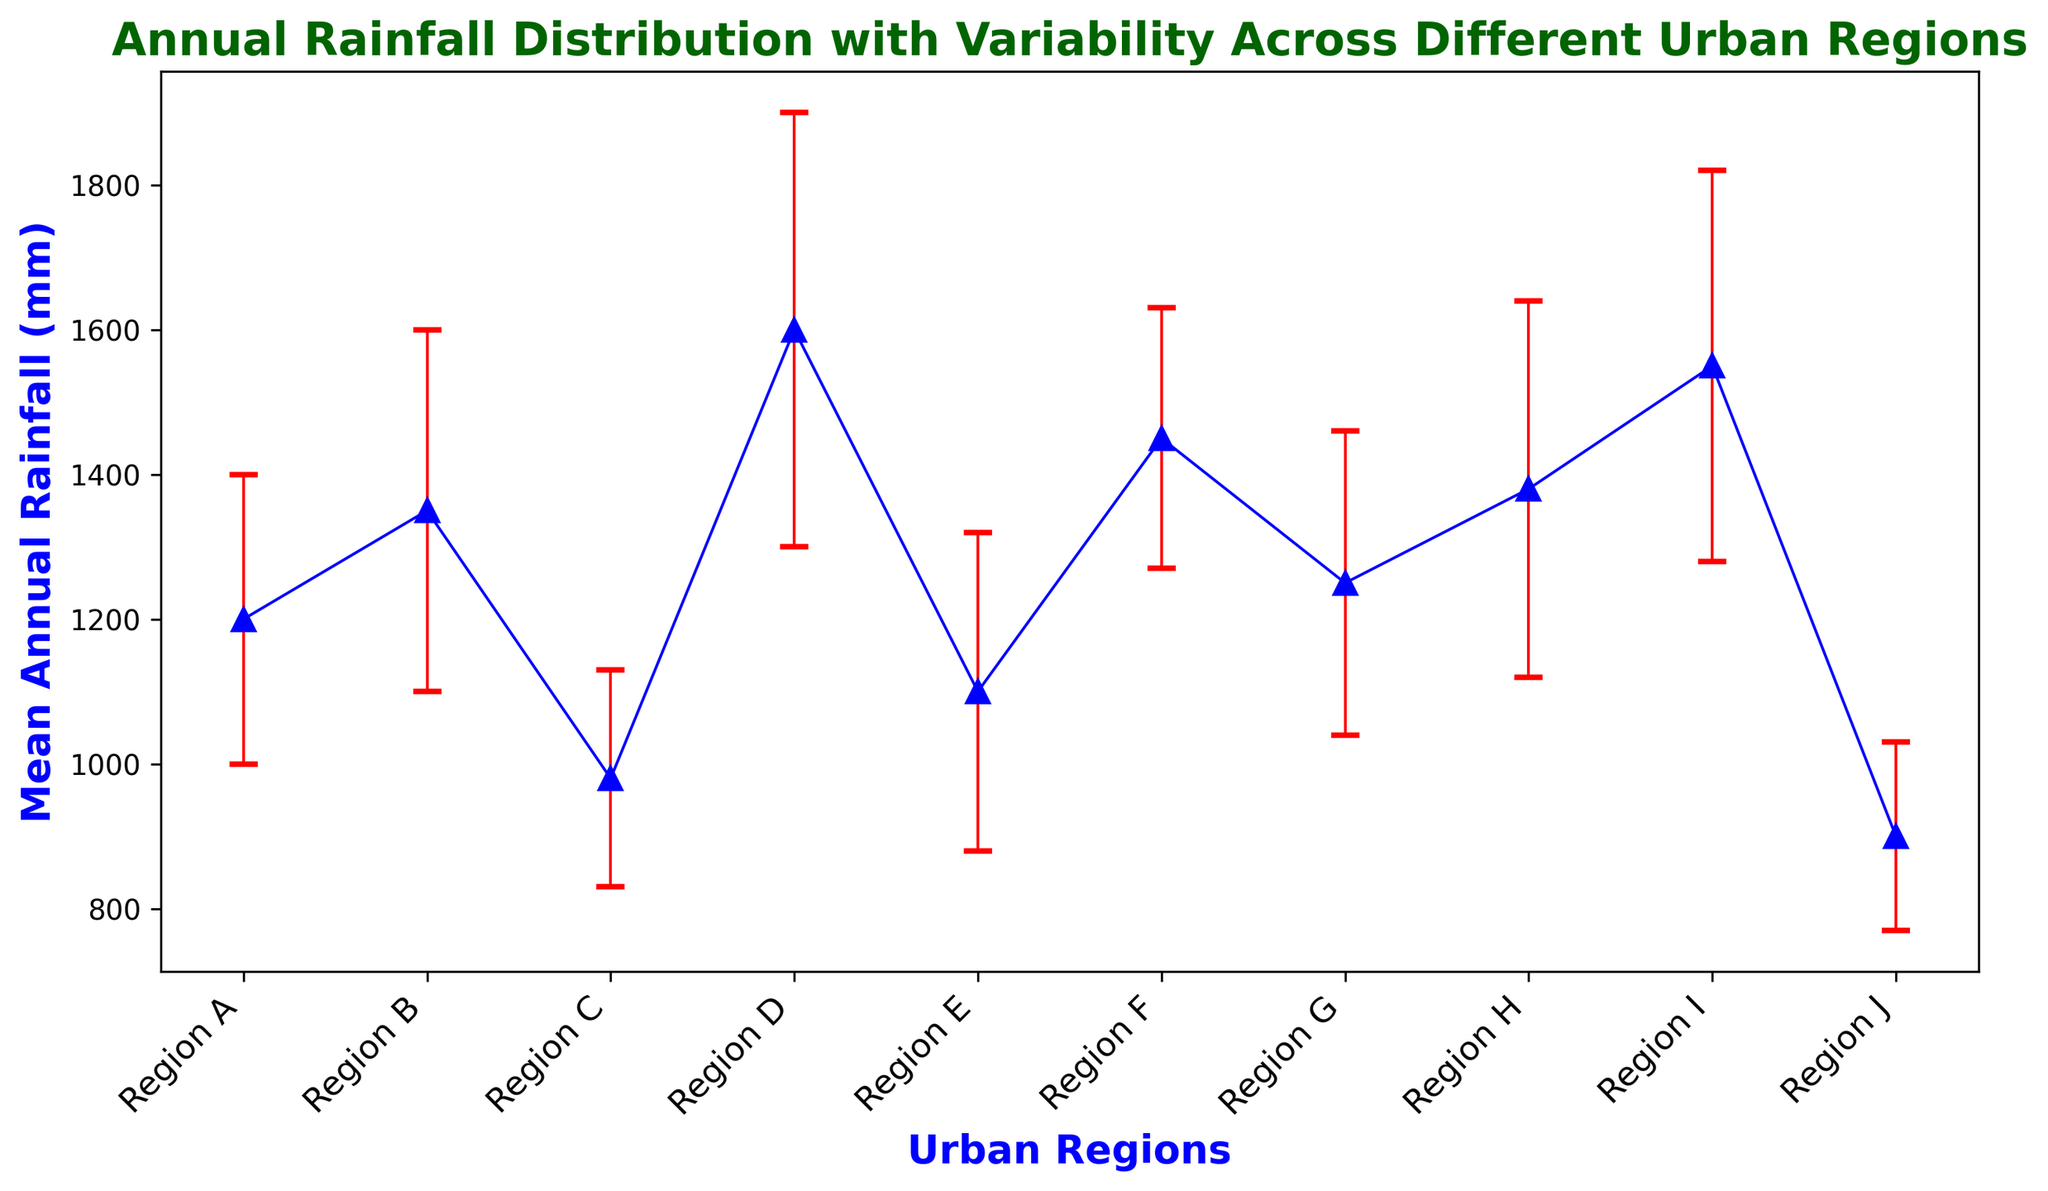Which region has the highest mean annual rainfall? Region D has the highest mean annual rainfall, as indicated by the tallest blue marker on the plot.
Answer: Region D Which region has the smallest variability in annual rainfall? Region J has the smallest standard deviation, represented by the smallest error bar in the chart.
Answer: Region J What is the difference in mean annual rainfall between Region B and Region C? Region B has a mean annual rainfall of 1350 mm, and Region C has 980 mm. The difference is 1350 - 980 = 370 mm.
Answer: 370 mm What is the average mean annual rainfall of Region E, F, and G? The mean annual rainfall for Region E, F, and G are 1100, 1450, and 1250 mm, respectively. The average is (1100 + 1450 + 1250) / 3 = 1266.67 mm.
Answer: 1266.67 mm Which region has a mean annual rainfall that is more than 1500 mm but less than 1600 mm? Region I has a mean annual rainfall of 1550 mm, which lies between 1500 mm and 1600 mm.
Answer: Region I Is the mean annual rainfall of Region H closer to Region B or Region G? The mean annual rainfall of Region H is 1380 mm, Region B is 1350 mm, and Region G is 1250 mm. The difference between Region H and B is 1380 - 1350 = 30 mm, and between Region H and G is 1380 - 1250 = 130 mm. Region H is closer to Region B.
Answer: Region B Identify the region with the second-highest variability in annual rainfall. The second-highest variability is represented by the second-largest error bar. Region I has the highest variability at 270 mm, and Region B has the second-highest at 250 mm.
Answer: Region B Compare the mean annual rainfall between Region A and Region F and state which one is greater and by how much. The mean annual rainfall of Region A is 1200 mm, and Region F is 1450 mm. Region F's mean is greater by 1450 - 1200 = 250 mm.
Answer: Region F, 250 mm What is the total mean annual rainfall for all 10 regions combined? Sum the mean annual rainfall of all regions: 1200 + 1350 + 980 + 1600 + 1100 + 1450 + 1250 + 1380 + 1550 + 900 = 13760 mm.
Answer: 13760 mm Which region has the median mean annual rainfall? Arrange the regions by mean annual rainfall values: 900, 980, 1100, 1200, 1250, 1350, 1380, 1450, 1550, 1600. The median value is the average of the 5th and 6th values: (1250 + 1350) / 2 = 1300 mm.
Answer: 1300 mm 